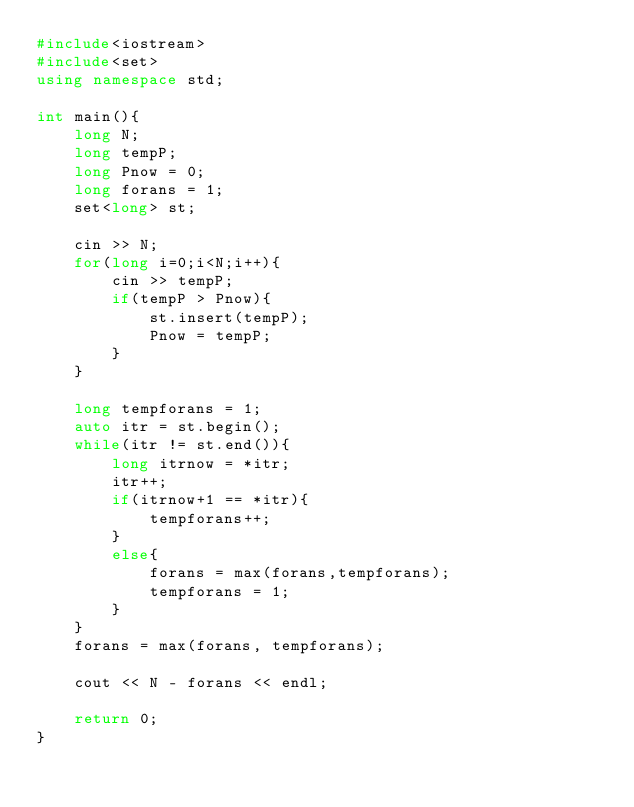Convert code to text. <code><loc_0><loc_0><loc_500><loc_500><_C++_>#include<iostream>
#include<set>
using namespace std;

int main(){
    long N;
    long tempP;
    long Pnow = 0;
    long forans = 1;
    set<long> st;

    cin >> N;
    for(long i=0;i<N;i++){
        cin >> tempP;
        if(tempP > Pnow){
            st.insert(tempP);
            Pnow = tempP;
        }
    }

    long tempforans = 1;
    auto itr = st.begin();
    while(itr != st.end()){
        long itrnow = *itr;
        itr++;
        if(itrnow+1 == *itr){
            tempforans++;
        }
        else{
            forans = max(forans,tempforans);
            tempforans = 1;
        }
    }
    forans = max(forans, tempforans);

    cout << N - forans << endl;

    return 0;
}</code> 